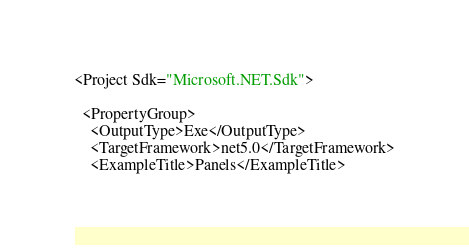<code> <loc_0><loc_0><loc_500><loc_500><_XML_><Project Sdk="Microsoft.NET.Sdk">

  <PropertyGroup>
    <OutputType>Exe</OutputType>
    <TargetFramework>net5.0</TargetFramework>
    <ExampleTitle>Panels</ExampleTitle></code> 